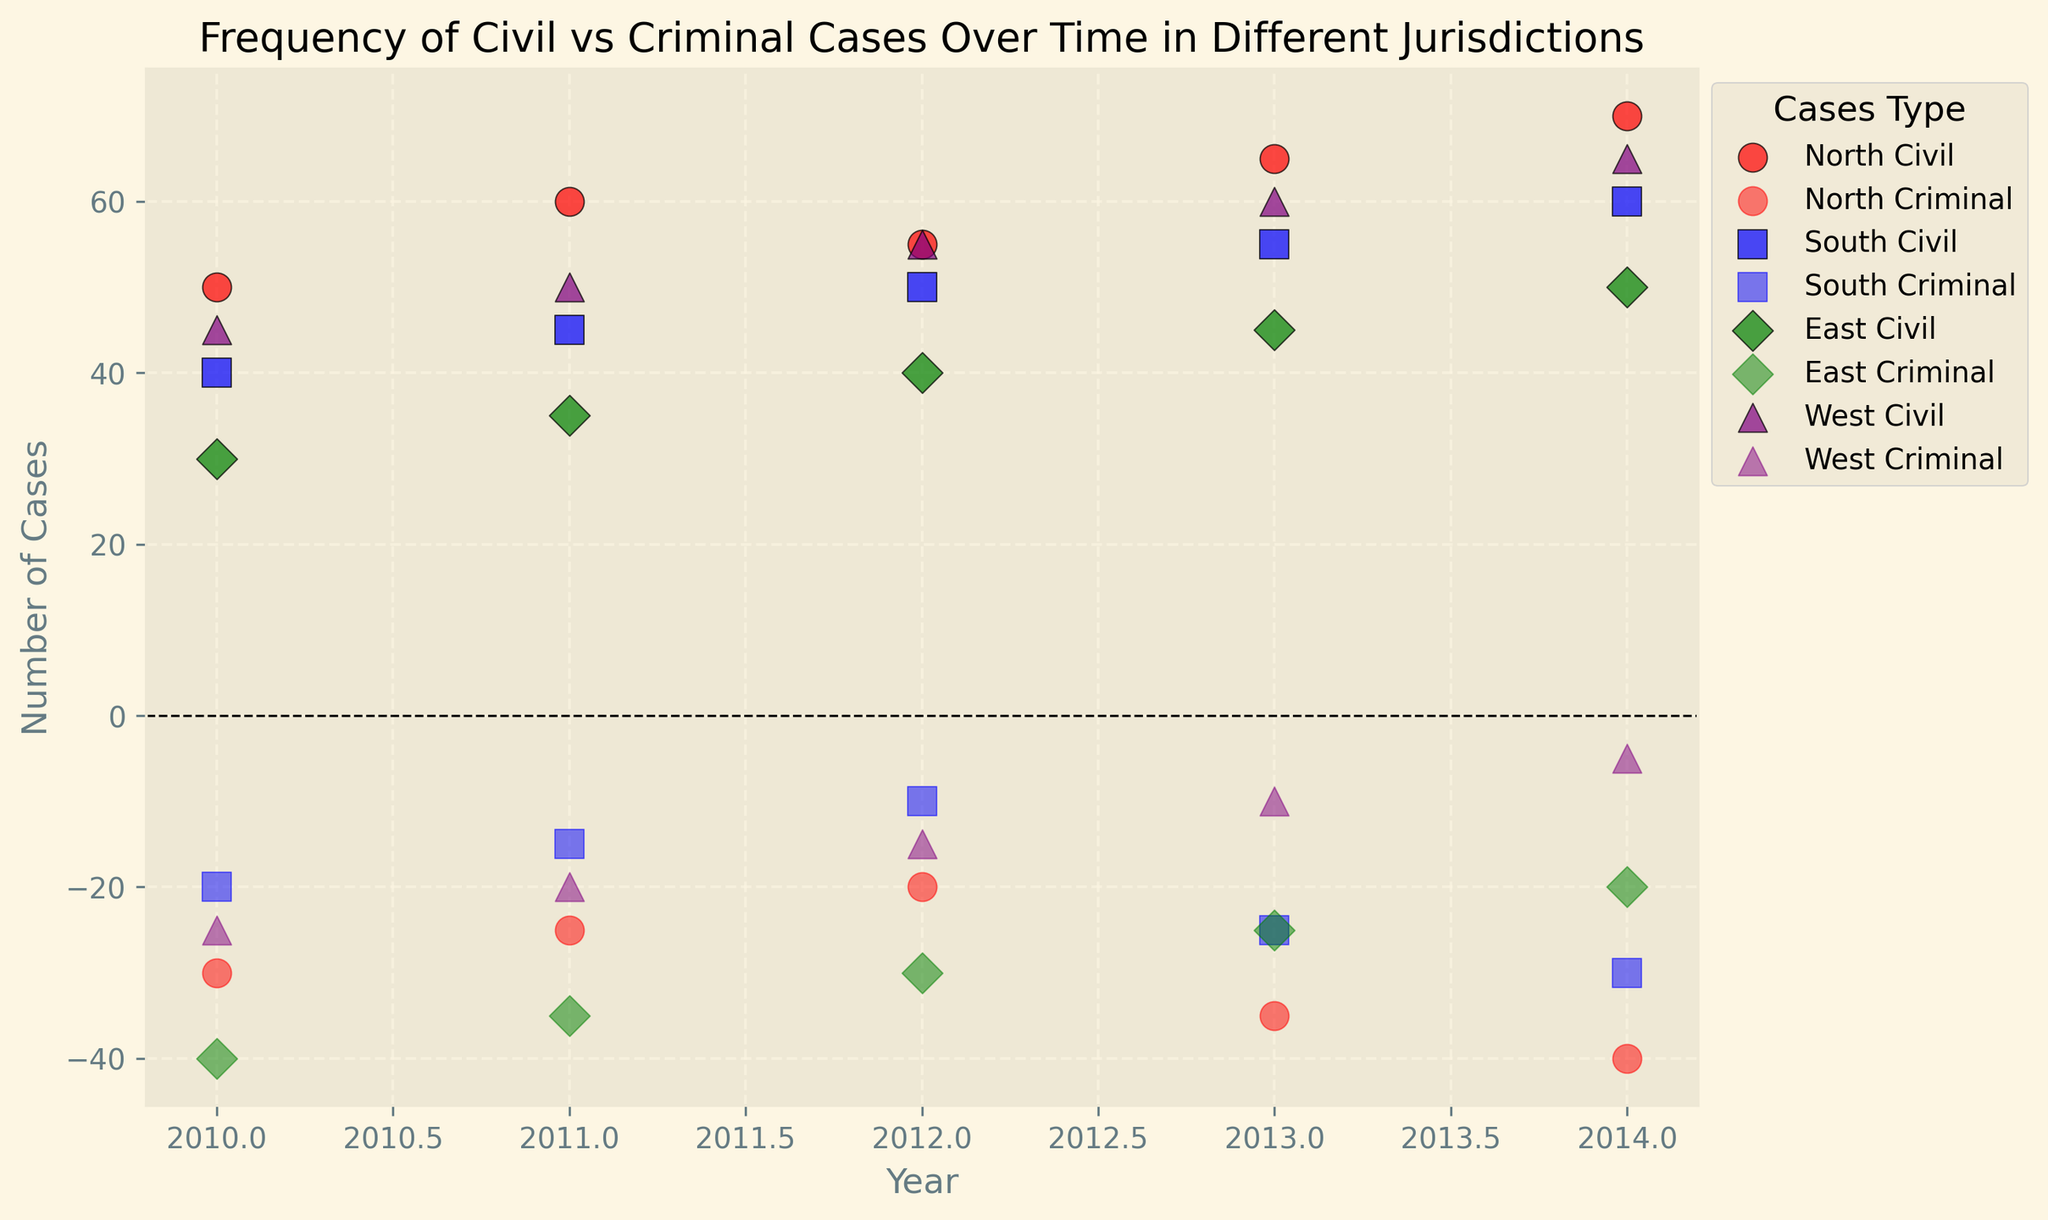What's the total number of civil cases in North from 2010 to 2014? Summing up the civil cases for North from 2010 to 2014: 50 + 60 + 55 + 65 + 70 = 300
Answer: 300 Which jurisdiction experienced the highest number of civil cases recorded in any single year? Identify the data points for civil cases in each jurisdiction and year, then find the maximum value. North in 2014 had the highest with 70 civil cases.
Answer: North In 2013, which jurisdiction had the smallest number of criminal cases? Compare the criminal case values for each jurisdiction in 2013. The East jurisdiction had the smallest number with -25 cases.
Answer: East By how much did the civil cases in South increase from 2010 to 2014? Subtract the number of civil cases in South in 2010 from the number in 2014: 60 - 40 = 20
Answer: 20 Did any jurisdictions have the same number of criminal cases in 2010? Check the criminal cases values for each jurisdiction in 2010. None of the values are the same.
Answer: No Is there any year where all jurisdictions reported negative criminal cases? Each year, check if all the criminal cases values are negative. For all years, criminal cases are negative in all jurisdictions.
Answer: Yes Which jurisdiction had the most stable (least change) number of civil cases from 2010 to 2014? Calculate the range (max - min) of civil cases for each jurisdiction. East had the range of 50 - 30 = 20, which is the smallest range.
Answer: East In which jurisdiction did the number of criminal cases decrease the most from 2010 to 2014? For each jurisdiction, compute the difference between 2010 and 2014 criminal cases: North (-30 to -40), South (-20 to -30), East (-40 to -20), West (-25 to -5). North had the largest decrease of 10 cases.
Answer: North 